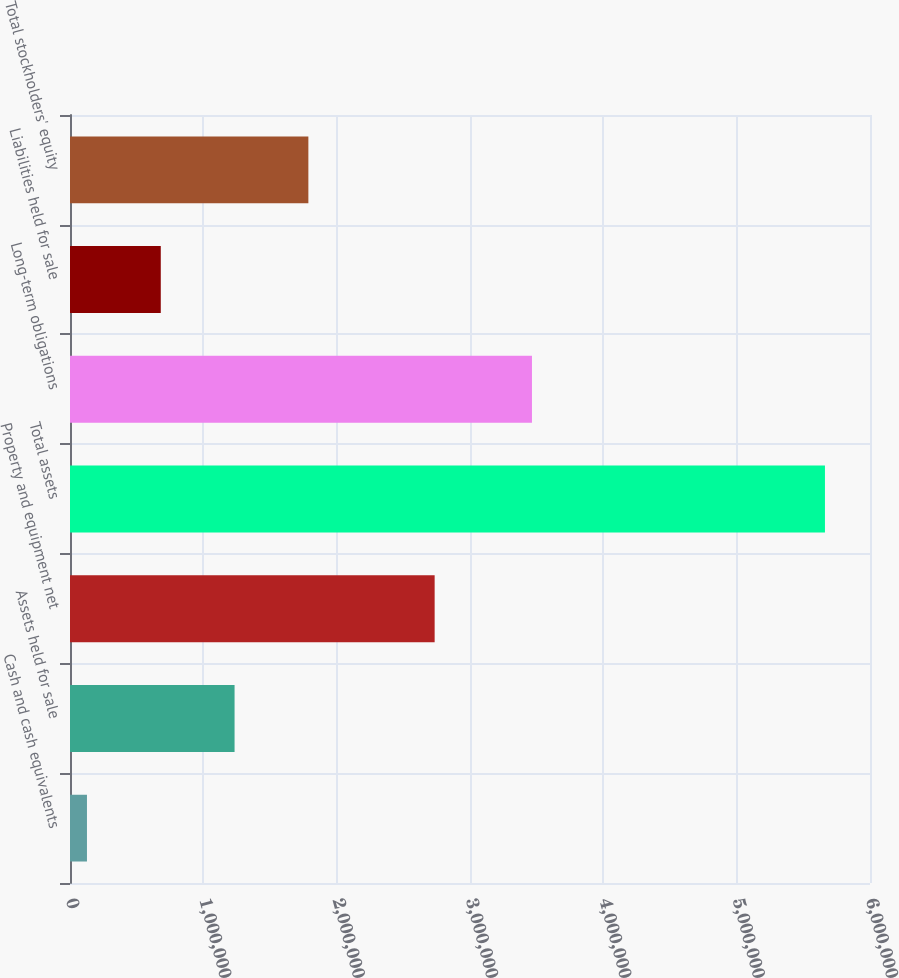Convert chart to OTSL. <chart><loc_0><loc_0><loc_500><loc_500><bar_chart><fcel>Cash and cash equivalents<fcel>Assets held for sale<fcel>Property and equipment net<fcel>Total assets<fcel>Long-term obligations<fcel>Liabilities held for sale<fcel>Total stockholders' equity<nl><fcel>127292<fcel>1.23427e+06<fcel>2.73488e+06<fcel>5.6622e+06<fcel>3.46468e+06<fcel>680783<fcel>1.78777e+06<nl></chart> 